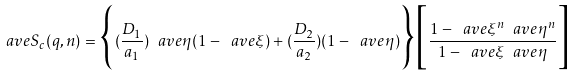<formula> <loc_0><loc_0><loc_500><loc_500>\ a v e { S _ { c } ( q , n ) } = \Big { \{ } ( \frac { D _ { 1 } } { a _ { 1 } } ) \ a v e { \eta } ( 1 - \ a v e { \xi } ) + ( \frac { D _ { 2 } } { a _ { 2 } } ) ( 1 - \ a v e { \eta } ) \Big { \} } \Big { [ } \frac { 1 - \ a v e { \xi } ^ { n } \ a v e { \eta } ^ { n } } { 1 - \ a v e { \xi } \ a v e { \eta } } \Big { ] }</formula> 